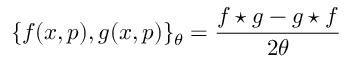<formula> <loc_0><loc_0><loc_500><loc_500>\{ f ( x , p ) , g ( x , p ) \} _ { \theta } = \frac { f ^ { * } g - g ^ { * } f } { 2 \theta }</formula> 